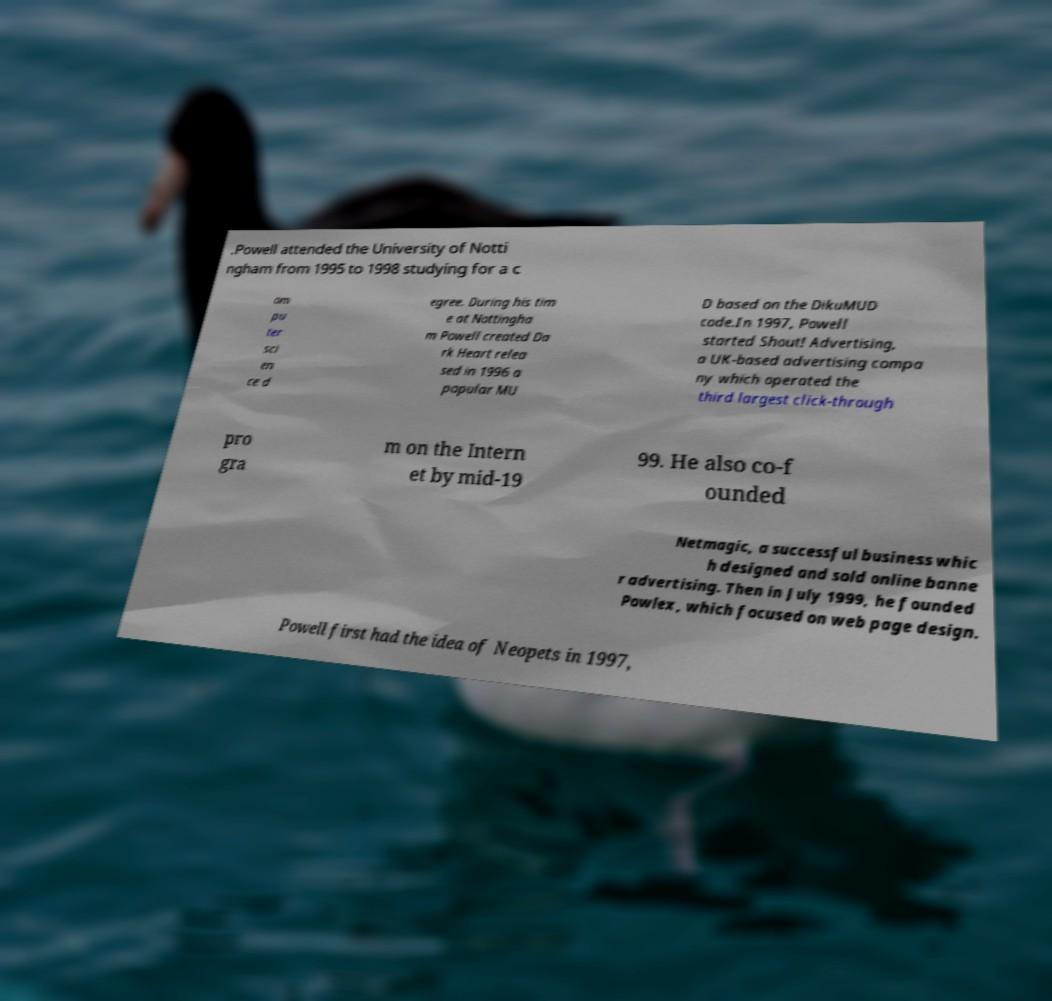I need the written content from this picture converted into text. Can you do that? .Powell attended the University of Notti ngham from 1995 to 1998 studying for a c om pu ter sci en ce d egree. During his tim e at Nottingha m Powell created Da rk Heart relea sed in 1996 a popular MU D based on the DikuMUD code.In 1997, Powell started Shout! Advertising, a UK-based advertising compa ny which operated the third largest click-through pro gra m on the Intern et by mid-19 99. He also co-f ounded Netmagic, a successful business whic h designed and sold online banne r advertising. Then in July 1999, he founded Powlex, which focused on web page design. Powell first had the idea of Neopets in 1997, 